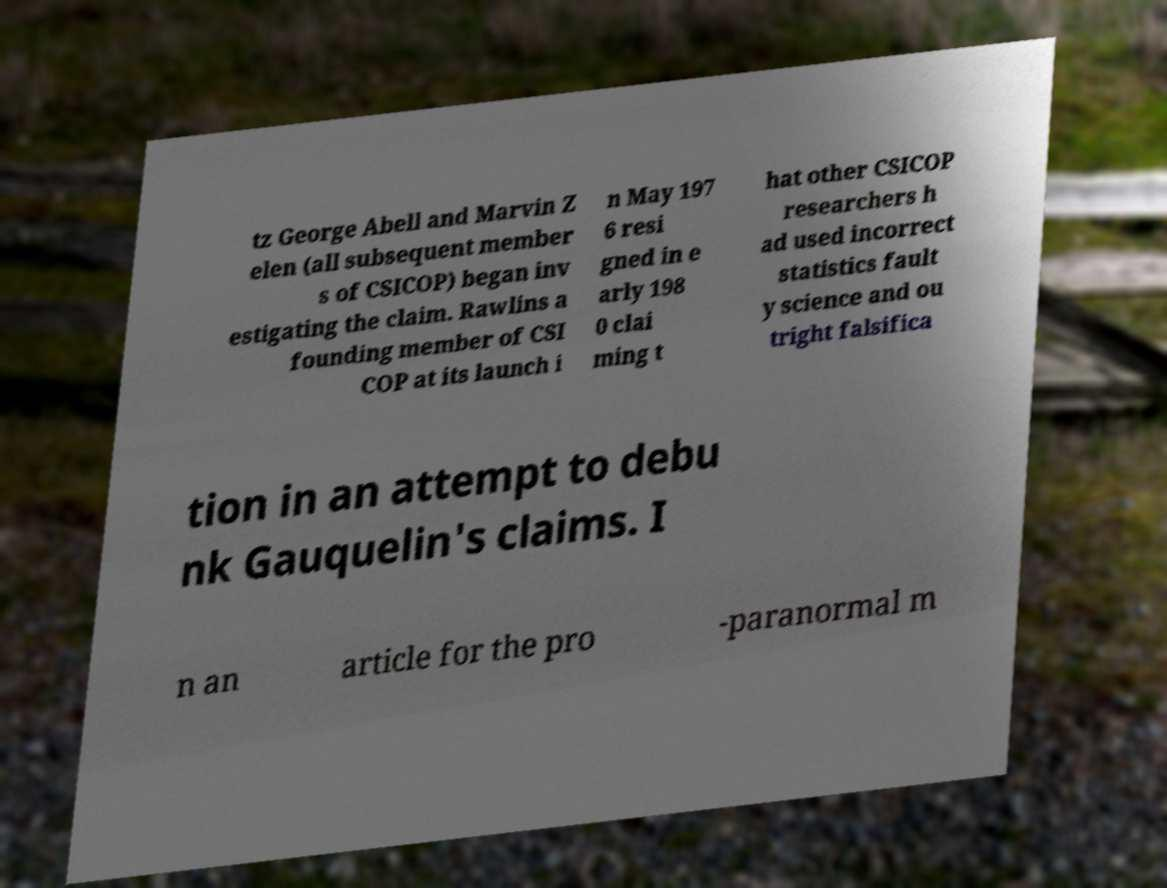For documentation purposes, I need the text within this image transcribed. Could you provide that? tz George Abell and Marvin Z elen (all subsequent member s of CSICOP) began inv estigating the claim. Rawlins a founding member of CSI COP at its launch i n May 197 6 resi gned in e arly 198 0 clai ming t hat other CSICOP researchers h ad used incorrect statistics fault y science and ou tright falsifica tion in an attempt to debu nk Gauquelin's claims. I n an article for the pro -paranormal m 